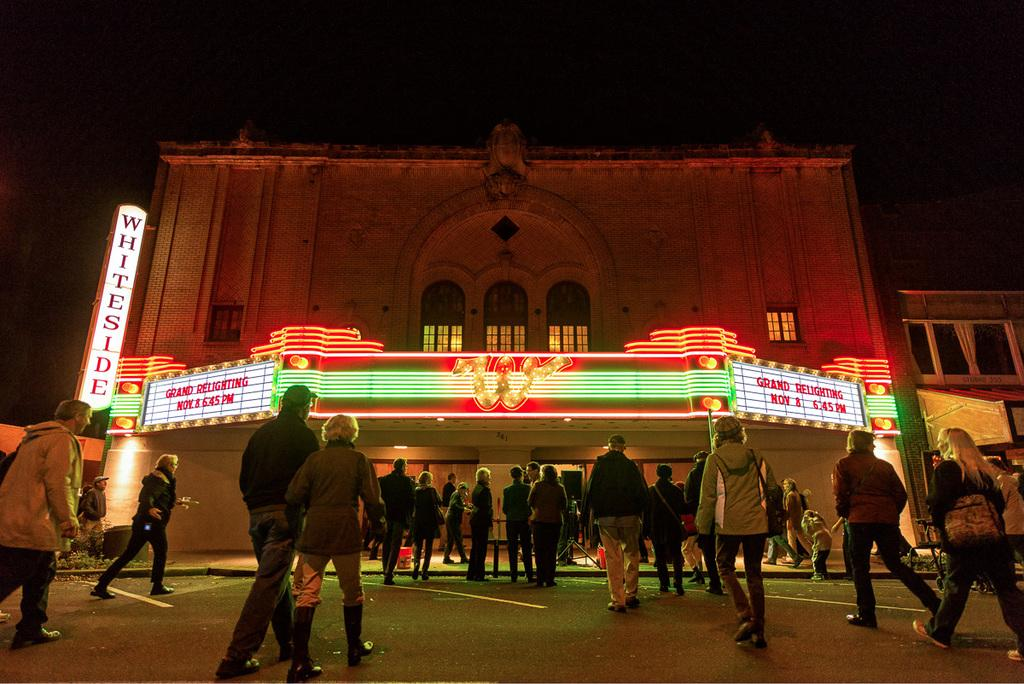What is happening in the image? There is a group of people standing in the image. What can be seen on the building in the image? There are light boards on the building. What is visible in the background of the image? The sky is visible in the image. How many clover leaves can be seen on the edge of the image? There are no clover leaves present in the image, as it features a group of people standing and light boards on a building. 